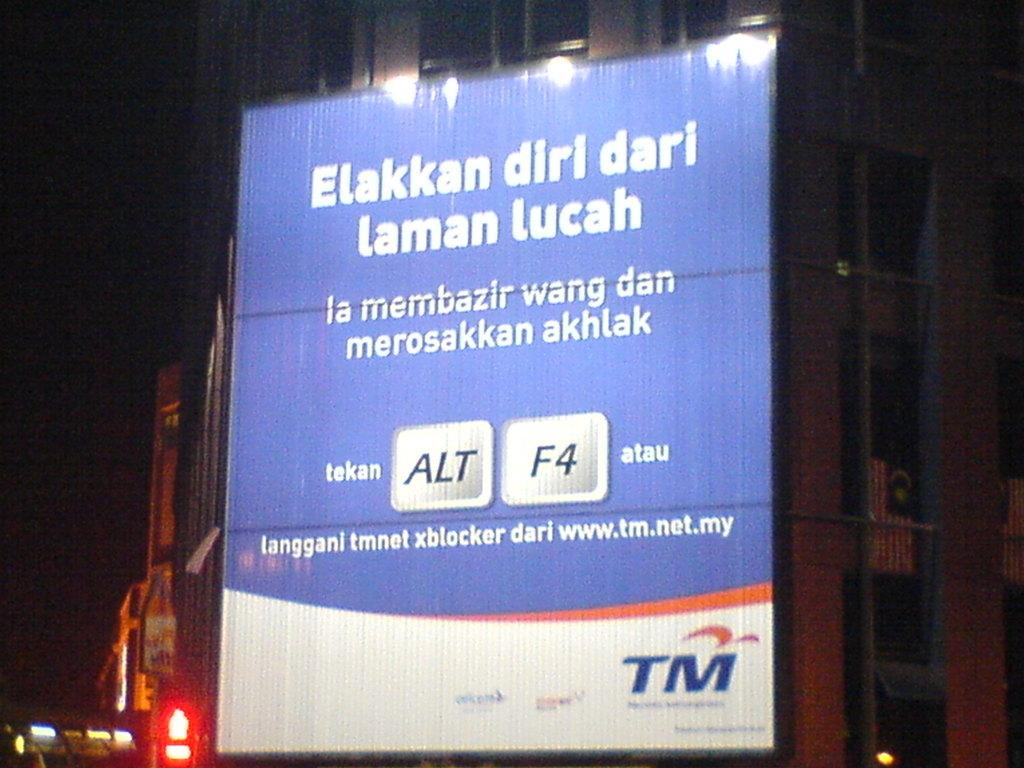What is hanging on the wall of the building in the foreground? A: There is a banner on the wall of a building in the foreground. What can be seen at the bottom of the image? There are lights at the bottom of the image. How would you describe the overall lighting in the image? The background of the image is dark, which contrasts with the lights at the bottom. How many boats are visible in the image? There are no boats present in the image. What type of chairs are used to support the banner in the image? There is no mention of chairs in the image, as the banner is hanging on the wall of a building. 